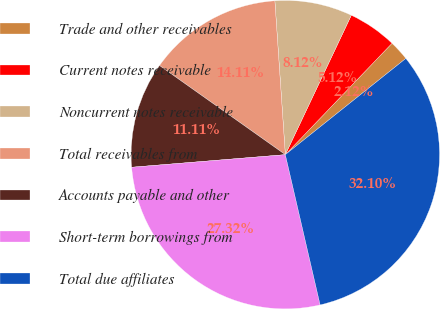Convert chart. <chart><loc_0><loc_0><loc_500><loc_500><pie_chart><fcel>Trade and other receivables<fcel>Current notes receivable<fcel>Noncurrent notes receivable<fcel>Total receivables from<fcel>Accounts payable and other<fcel>Short-term borrowings from<fcel>Total due affiliates<nl><fcel>2.12%<fcel>5.12%<fcel>8.12%<fcel>14.11%<fcel>11.11%<fcel>27.32%<fcel>32.1%<nl></chart> 